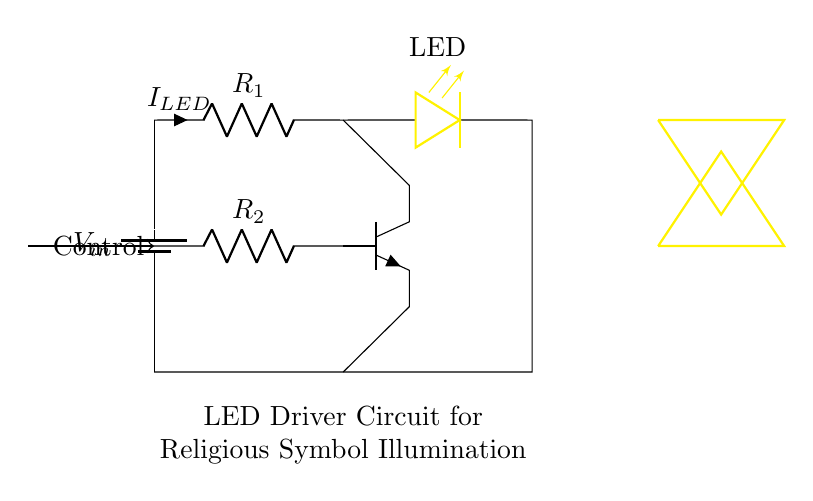What is the input voltage of this circuit? The input voltage can be found at the battery symbol labeled V_in in the circuit diagram. It represents the power supply voltage connected to the circuit.
Answer: V_in What type of transistor is used in this circuit? The circuit shows an NPN transistor, which can be identified by the label "npn" and its symbol, indicating its configuration for switching or amplification in the LED driver application.
Answer: NPN What is the purpose of the resistor R2? Resistor R2 is connected to the base of the NPN transistor, providing biasing to control the transistor's operation and allowing the current to flow when the control signal is applied.
Answer: Biasing What happens when the control signal is applied? When the control signal activates, it allows current to flow through R2, which turns on the NPN transistor. This then allows current to flow from the power supply through the LED, illuminating it as part of the driver circuit.
Answer: LED illuminates What is the relationship between R1 and I_LED? Resistor R1 limits the amount of current flowing through the LED (I_LED) to prevent damage to it. According to Ohm's law, if R1 increases, I_LED decreases, and vice versa, unless voltage V_in changes.
Answer: Current limiting What does the Star of David represent in this circuit? The Star of David symbolizes a religious or cultural emblem, demonstrating the intended application of the LED driver circuit for illuminating significant artifacts or symbols in a religious context.
Answer: Religious symbol 